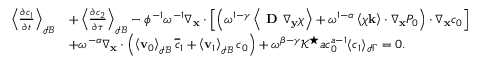<formula> <loc_0><loc_0><loc_500><loc_500>\begin{array} { r l } { \left \langle \frac { \partial c _ { 1 } } { \partial t } \right \rangle _ { \mathcal { I B } } } & { + \left \langle \frac { \partial c _ { 2 } } { \partial \tau } \right \rangle _ { \mathcal { I B } } - \phi ^ { - 1 } \omega ^ { - 1 } \nabla _ { x } \cdot \left [ \left ( \omega ^ { 1 - \gamma } \left \langle D \nabla _ { \mathbf y } \boldsymbol \chi \right \rangle + \omega ^ { 1 - \alpha } \left \langle \boldsymbol \chi \mathbf k \right \rangle \cdot \nabla _ { \mathbf x } P _ { 0 } \right ) \cdot \nabla _ { \mathbf x } c _ { 0 } \right ] } \\ & { + \omega ^ { - \alpha } \nabla _ { \mathbf x } \cdot \left ( \left \langle \mathbf v _ { 0 } \right \rangle _ { \mathcal { I B } } \overline { c } _ { 1 } + \left \langle \mathbf v _ { 1 } \right \rangle _ { \mathcal { I B } } c _ { 0 } \right ) + \omega ^ { \beta - \gamma } \mathcal { K ^ { ^ { * } } } a c _ { 0 } ^ { a - 1 } \langle c _ { 1 } \rangle _ { \mathcal { I } \Gamma } = 0 . } \end{array}</formula> 